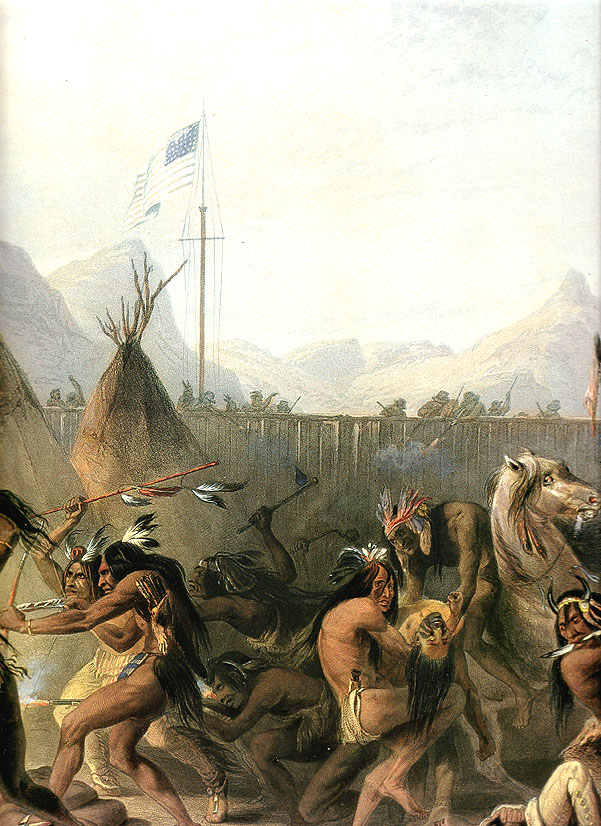Can you tell me about the cultural significance of the dance depicted in this painting? The dance depicted in this painting likely holds deep cultural significance for the Native American tribe shown. Traditional dances are often an integral part of indigenous cultures, serving as a means of expressing spirituality, telling stories, and preserving cultural heritage. These dances can be performed during ceremonies, celebrations, or to mark seasonal changes, and they often involve intricate movements, symbolic attire, and music. In this painting, the rhythmic motion of the figures and their traditional clothing suggest a joyous or ceremonial occasion, highlighting the importance of dance in fostering community bonds and maintaining cultural identity. What do you think the presence of the American flag signifies in this scene? The American flag in this scene likely symbolizes the complex and often contentious history between Native Americans and the US government. Its prominent position in the midst of a traditional Native American gathering could represent various themes, such as the imposition of American authority, the blending of cultures, or a marker of a specific historical event where both entities were involved. The contrast between the flag and the traditional dance may also evoke reflections on the impact of colonization, the resilience of Native cultures, and the ongoing struggles for sovereignty and cultural preservation. Can you describe the landscape in which this scene is set and its significance? The landscape in the painting features calm mountains and scattered trees, creating a serene backdrop for the dynamic dance in the foreground. This natural setting is significant as it reflects the deep connection that many Native American cultures have with the land. The mountains suggest a sense of enduring strength and stability, mirroring the resilience of the people portrayed. The trees and open space might symbolize freedom and the vast expanse of native territories before widespread settlement. This juxtaposition of nature and human activity enriches the narrative, underscoring themes of harmony with the environment and the disruption brought by external forces. 